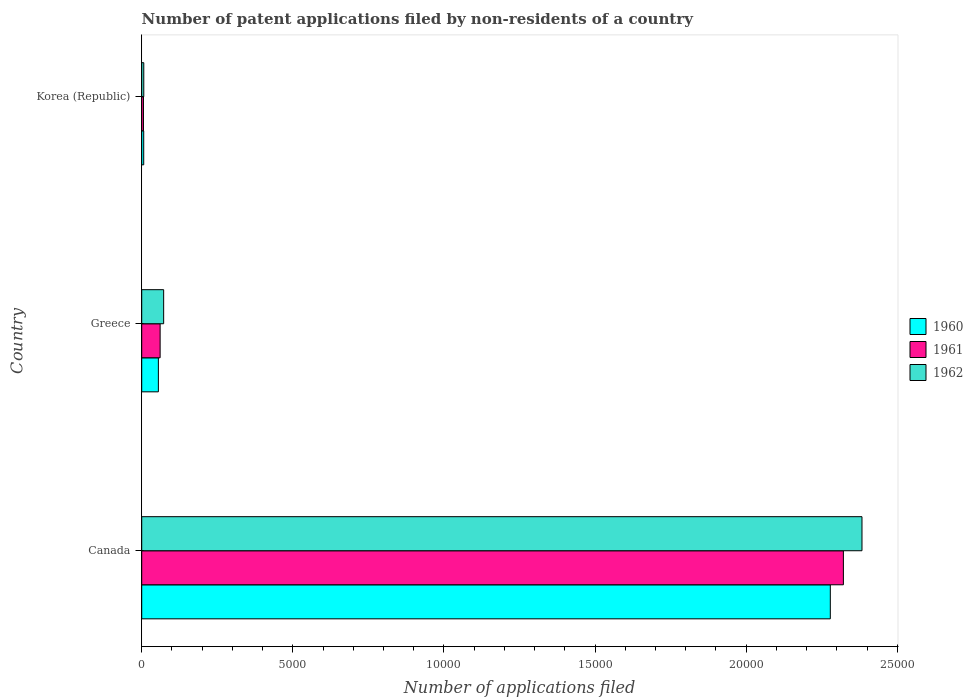How many different coloured bars are there?
Offer a terse response. 3. How many groups of bars are there?
Make the answer very short. 3. Are the number of bars on each tick of the Y-axis equal?
Your answer should be compact. Yes. How many bars are there on the 1st tick from the bottom?
Ensure brevity in your answer.  3. What is the number of applications filed in 1962 in Korea (Republic)?
Keep it short and to the point. 68. Across all countries, what is the maximum number of applications filed in 1960?
Your response must be concise. 2.28e+04. Across all countries, what is the minimum number of applications filed in 1960?
Keep it short and to the point. 66. In which country was the number of applications filed in 1962 maximum?
Make the answer very short. Canada. What is the total number of applications filed in 1962 in the graph?
Ensure brevity in your answer.  2.46e+04. What is the difference between the number of applications filed in 1962 in Canada and that in Korea (Republic)?
Make the answer very short. 2.38e+04. What is the difference between the number of applications filed in 1962 in Greece and the number of applications filed in 1960 in Korea (Republic)?
Your answer should be compact. 660. What is the average number of applications filed in 1962 per country?
Give a very brief answer. 8209.33. What is the ratio of the number of applications filed in 1962 in Greece to that in Korea (Republic)?
Your answer should be very brief. 10.68. Is the number of applications filed in 1961 in Greece less than that in Korea (Republic)?
Give a very brief answer. No. Is the difference between the number of applications filed in 1962 in Canada and Korea (Republic) greater than the difference between the number of applications filed in 1960 in Canada and Korea (Republic)?
Give a very brief answer. Yes. What is the difference between the highest and the second highest number of applications filed in 1962?
Your response must be concise. 2.31e+04. What is the difference between the highest and the lowest number of applications filed in 1962?
Keep it short and to the point. 2.38e+04. What does the 3rd bar from the top in Canada represents?
Make the answer very short. 1960. What does the 3rd bar from the bottom in Korea (Republic) represents?
Keep it short and to the point. 1962. Is it the case that in every country, the sum of the number of applications filed in 1961 and number of applications filed in 1962 is greater than the number of applications filed in 1960?
Your answer should be compact. Yes. Are all the bars in the graph horizontal?
Give a very brief answer. Yes. How many countries are there in the graph?
Offer a terse response. 3. What is the difference between two consecutive major ticks on the X-axis?
Keep it short and to the point. 5000. Does the graph contain grids?
Offer a terse response. No. Where does the legend appear in the graph?
Your response must be concise. Center right. What is the title of the graph?
Ensure brevity in your answer.  Number of patent applications filed by non-residents of a country. Does "1990" appear as one of the legend labels in the graph?
Make the answer very short. No. What is the label or title of the X-axis?
Give a very brief answer. Number of applications filed. What is the label or title of the Y-axis?
Keep it short and to the point. Country. What is the Number of applications filed in 1960 in Canada?
Keep it short and to the point. 2.28e+04. What is the Number of applications filed in 1961 in Canada?
Your answer should be very brief. 2.32e+04. What is the Number of applications filed in 1962 in Canada?
Make the answer very short. 2.38e+04. What is the Number of applications filed in 1960 in Greece?
Provide a succinct answer. 551. What is the Number of applications filed of 1961 in Greece?
Your response must be concise. 609. What is the Number of applications filed in 1962 in Greece?
Keep it short and to the point. 726. What is the Number of applications filed of 1960 in Korea (Republic)?
Your answer should be very brief. 66. What is the Number of applications filed in 1961 in Korea (Republic)?
Give a very brief answer. 58. Across all countries, what is the maximum Number of applications filed in 1960?
Provide a succinct answer. 2.28e+04. Across all countries, what is the maximum Number of applications filed of 1961?
Make the answer very short. 2.32e+04. Across all countries, what is the maximum Number of applications filed of 1962?
Keep it short and to the point. 2.38e+04. What is the total Number of applications filed in 1960 in the graph?
Your response must be concise. 2.34e+04. What is the total Number of applications filed of 1961 in the graph?
Your response must be concise. 2.39e+04. What is the total Number of applications filed of 1962 in the graph?
Your answer should be very brief. 2.46e+04. What is the difference between the Number of applications filed of 1960 in Canada and that in Greece?
Provide a short and direct response. 2.22e+04. What is the difference between the Number of applications filed in 1961 in Canada and that in Greece?
Provide a short and direct response. 2.26e+04. What is the difference between the Number of applications filed of 1962 in Canada and that in Greece?
Your answer should be compact. 2.31e+04. What is the difference between the Number of applications filed in 1960 in Canada and that in Korea (Republic)?
Your answer should be very brief. 2.27e+04. What is the difference between the Number of applications filed of 1961 in Canada and that in Korea (Republic)?
Give a very brief answer. 2.32e+04. What is the difference between the Number of applications filed of 1962 in Canada and that in Korea (Republic)?
Your response must be concise. 2.38e+04. What is the difference between the Number of applications filed in 1960 in Greece and that in Korea (Republic)?
Give a very brief answer. 485. What is the difference between the Number of applications filed in 1961 in Greece and that in Korea (Republic)?
Keep it short and to the point. 551. What is the difference between the Number of applications filed of 1962 in Greece and that in Korea (Republic)?
Offer a very short reply. 658. What is the difference between the Number of applications filed of 1960 in Canada and the Number of applications filed of 1961 in Greece?
Ensure brevity in your answer.  2.22e+04. What is the difference between the Number of applications filed of 1960 in Canada and the Number of applications filed of 1962 in Greece?
Give a very brief answer. 2.21e+04. What is the difference between the Number of applications filed of 1961 in Canada and the Number of applications filed of 1962 in Greece?
Your response must be concise. 2.25e+04. What is the difference between the Number of applications filed of 1960 in Canada and the Number of applications filed of 1961 in Korea (Republic)?
Give a very brief answer. 2.27e+04. What is the difference between the Number of applications filed of 1960 in Canada and the Number of applications filed of 1962 in Korea (Republic)?
Keep it short and to the point. 2.27e+04. What is the difference between the Number of applications filed of 1961 in Canada and the Number of applications filed of 1962 in Korea (Republic)?
Keep it short and to the point. 2.32e+04. What is the difference between the Number of applications filed in 1960 in Greece and the Number of applications filed in 1961 in Korea (Republic)?
Provide a succinct answer. 493. What is the difference between the Number of applications filed in 1960 in Greece and the Number of applications filed in 1962 in Korea (Republic)?
Offer a terse response. 483. What is the difference between the Number of applications filed of 1961 in Greece and the Number of applications filed of 1962 in Korea (Republic)?
Your answer should be very brief. 541. What is the average Number of applications filed of 1960 per country?
Make the answer very short. 7801. What is the average Number of applications filed in 1961 per country?
Offer a very short reply. 7962. What is the average Number of applications filed in 1962 per country?
Keep it short and to the point. 8209.33. What is the difference between the Number of applications filed of 1960 and Number of applications filed of 1961 in Canada?
Offer a terse response. -433. What is the difference between the Number of applications filed in 1960 and Number of applications filed in 1962 in Canada?
Make the answer very short. -1048. What is the difference between the Number of applications filed of 1961 and Number of applications filed of 1962 in Canada?
Your response must be concise. -615. What is the difference between the Number of applications filed of 1960 and Number of applications filed of 1961 in Greece?
Offer a very short reply. -58. What is the difference between the Number of applications filed of 1960 and Number of applications filed of 1962 in Greece?
Your answer should be very brief. -175. What is the difference between the Number of applications filed in 1961 and Number of applications filed in 1962 in Greece?
Your answer should be very brief. -117. What is the difference between the Number of applications filed in 1960 and Number of applications filed in 1961 in Korea (Republic)?
Your response must be concise. 8. What is the ratio of the Number of applications filed of 1960 in Canada to that in Greece?
Offer a terse response. 41.35. What is the ratio of the Number of applications filed in 1961 in Canada to that in Greece?
Provide a succinct answer. 38.13. What is the ratio of the Number of applications filed in 1962 in Canada to that in Greece?
Ensure brevity in your answer.  32.83. What is the ratio of the Number of applications filed in 1960 in Canada to that in Korea (Republic)?
Provide a short and direct response. 345.24. What is the ratio of the Number of applications filed of 1961 in Canada to that in Korea (Republic)?
Give a very brief answer. 400.33. What is the ratio of the Number of applications filed of 1962 in Canada to that in Korea (Republic)?
Give a very brief answer. 350.5. What is the ratio of the Number of applications filed of 1960 in Greece to that in Korea (Republic)?
Offer a very short reply. 8.35. What is the ratio of the Number of applications filed of 1961 in Greece to that in Korea (Republic)?
Make the answer very short. 10.5. What is the ratio of the Number of applications filed in 1962 in Greece to that in Korea (Republic)?
Offer a very short reply. 10.68. What is the difference between the highest and the second highest Number of applications filed in 1960?
Your response must be concise. 2.22e+04. What is the difference between the highest and the second highest Number of applications filed of 1961?
Ensure brevity in your answer.  2.26e+04. What is the difference between the highest and the second highest Number of applications filed of 1962?
Provide a succinct answer. 2.31e+04. What is the difference between the highest and the lowest Number of applications filed of 1960?
Keep it short and to the point. 2.27e+04. What is the difference between the highest and the lowest Number of applications filed of 1961?
Offer a very short reply. 2.32e+04. What is the difference between the highest and the lowest Number of applications filed in 1962?
Offer a terse response. 2.38e+04. 